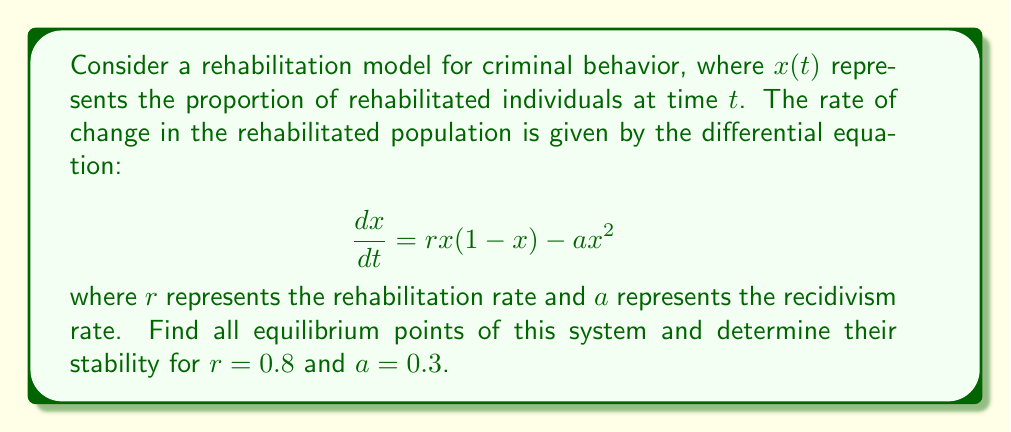Give your solution to this math problem. 1. To find the equilibrium points, set $\frac{dx}{dt} = 0$:

   $$rx(1-x) - ax^2 = 0$$

2. Factor out $x$:

   $$x(r(1-x) - ax) = 0$$

3. Solve for $x$:
   
   $x = 0$ or $r(1-x) - ax = 0$

4. For the second equation:
   
   $r - rx - ax = 0$
   $r = x(r + a)$
   $x = \frac{r}{r+a}$

5. Therefore, the equilibrium points are:
   
   $x_1 = 0$ and $x_2 = \frac{r}{r+a}$

6. Substitute the given values $r = 0.8$ and $a = 0.3$:
   
   $x_1 = 0$ and $x_2 = \frac{0.8}{0.8+0.3} = \frac{0.8}{1.1} \approx 0.7273$

7. To determine stability, evaluate $\frac{d}{dx}(\frac{dx}{dt})$ at each equilibrium point:

   $$\frac{d}{dx}(\frac{dx}{dt}) = r(1-2x) - 2ax$$

8. At $x_1 = 0$:
   
   $\frac{d}{dx}(\frac{dx}{dt})|_{x=0} = r = 0.8 > 0$, so $x_1$ is unstable.

9. At $x_2 \approx 0.7273$:
   
   $\frac{d}{dx}(\frac{dx}{dt})|_{x=0.7273} = 0.8(1-2(0.7273)) - 2(0.3)(0.7273) \approx -0.7273 < 0$, so $x_2$ is stable.
Answer: Two equilibrium points: $x_1 = 0$ (unstable) and $x_2 \approx 0.7273$ (stable). 